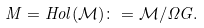<formula> <loc_0><loc_0><loc_500><loc_500>M = H o l ( \mathcal { M } ) \colon = \mathcal { M } / \Omega G .</formula> 